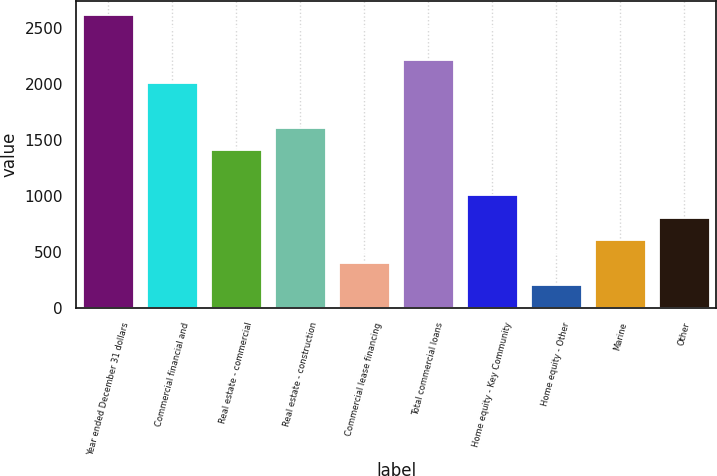Convert chart. <chart><loc_0><loc_0><loc_500><loc_500><bar_chart><fcel>Year ended December 31 dollars<fcel>Commercial financial and<fcel>Real estate - commercial<fcel>Real estate - construction<fcel>Commercial lease financing<fcel>Total commercial loans<fcel>Home equity - Key Community<fcel>Home equity - Other<fcel>Marine<fcel>Other<nl><fcel>2612.14<fcel>2010.01<fcel>1407.88<fcel>1608.59<fcel>404.33<fcel>2210.72<fcel>1006.46<fcel>203.62<fcel>605.04<fcel>805.75<nl></chart> 